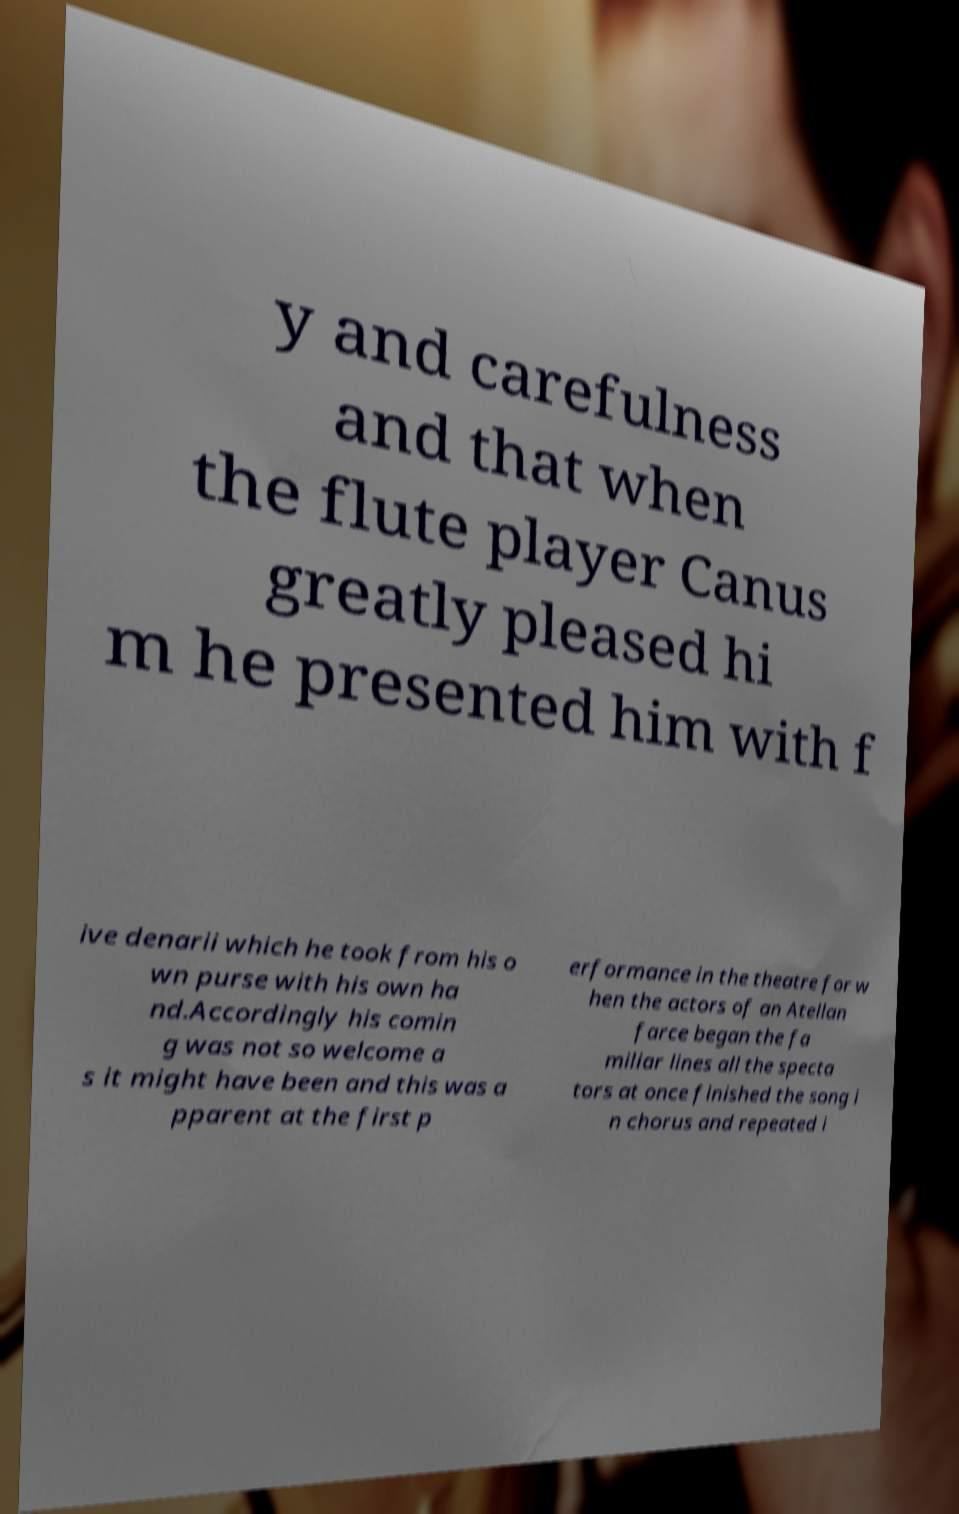There's text embedded in this image that I need extracted. Can you transcribe it verbatim? y and carefulness and that when the flute player Canus greatly pleased hi m he presented him with f ive denarii which he took from his o wn purse with his own ha nd.Accordingly his comin g was not so welcome a s it might have been and this was a pparent at the first p erformance in the theatre for w hen the actors of an Atellan farce began the fa miliar lines all the specta tors at once finished the song i n chorus and repeated i 